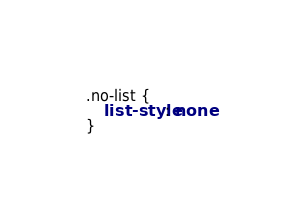Convert code to text. <code><loc_0><loc_0><loc_500><loc_500><_CSS_>.no-list {
    list-style: none
}</code> 